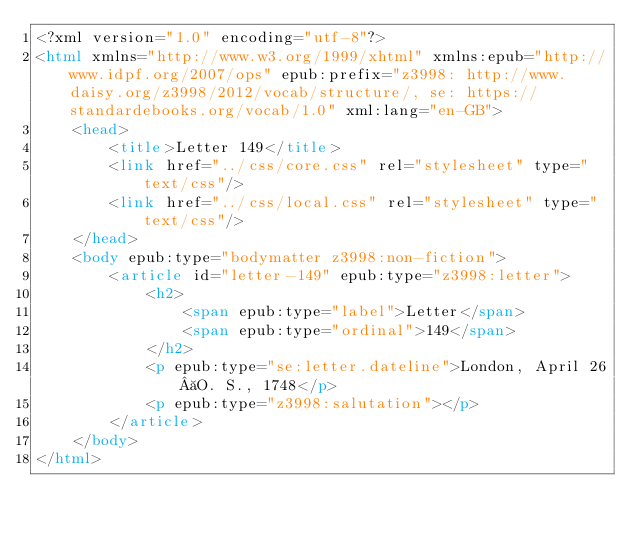Convert code to text. <code><loc_0><loc_0><loc_500><loc_500><_HTML_><?xml version="1.0" encoding="utf-8"?>
<html xmlns="http://www.w3.org/1999/xhtml" xmlns:epub="http://www.idpf.org/2007/ops" epub:prefix="z3998: http://www.daisy.org/z3998/2012/vocab/structure/, se: https://standardebooks.org/vocab/1.0" xml:lang="en-GB">
	<head>
		<title>Letter 149</title>
		<link href="../css/core.css" rel="stylesheet" type="text/css"/>
		<link href="../css/local.css" rel="stylesheet" type="text/css"/>
	</head>
	<body epub:type="bodymatter z3998:non-fiction">
		<article id="letter-149" epub:type="z3998:letter">
			<h2>
				<span epub:type="label">Letter</span>
				<span epub:type="ordinal">149</span>
			</h2>
			<p epub:type="se:letter.dateline">London, April 26 O. S., 1748</p>
			<p epub:type="z3998:salutation"></p>
		</article>
	</body>
</html>
</code> 